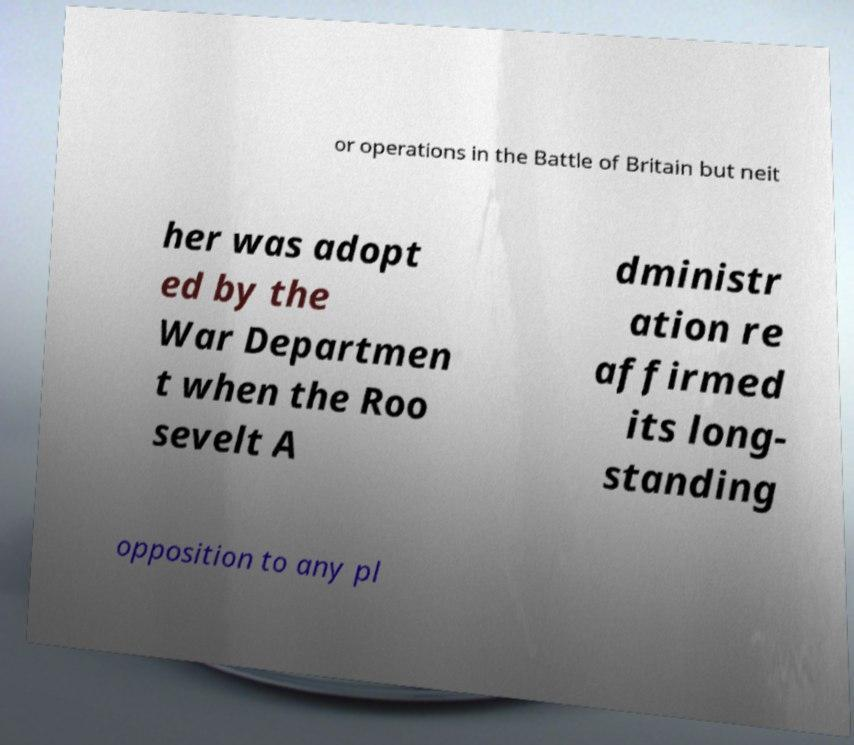Please identify and transcribe the text found in this image. or operations in the Battle of Britain but neit her was adopt ed by the War Departmen t when the Roo sevelt A dministr ation re affirmed its long- standing opposition to any pl 